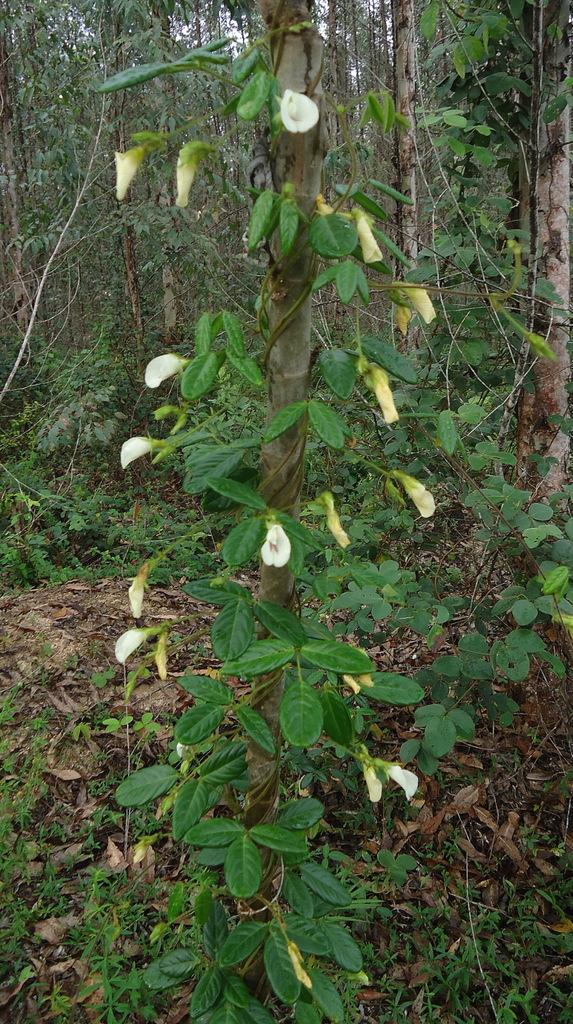What type of plant is in the image? The plant in the image has white flowers. What can be seen in the background of the image? There are trees in the background of the image. What is present on the floor in the image? Dry leaves are present on the floor in the image. What type of sea creature can be seen swimming near the plant in the image? There is no sea creature present in the image, as it features a plant with white flowers and a background of trees. 